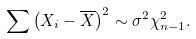Convert formula to latex. <formula><loc_0><loc_0><loc_500><loc_500>\sum \left ( X _ { i } - { \overline { X } } \right ) ^ { 2 } \sim \sigma ^ { 2 } \chi _ { n - 1 } ^ { 2 } .</formula> 